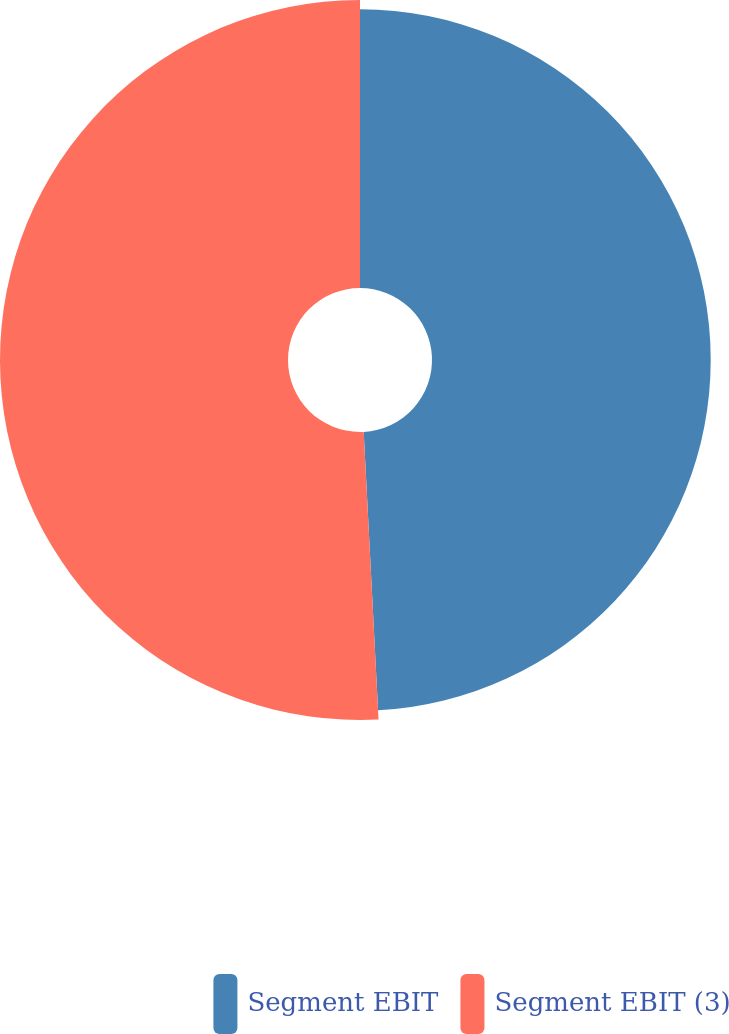<chart> <loc_0><loc_0><loc_500><loc_500><pie_chart><fcel>Segment EBIT<fcel>Segment EBIT (3)<nl><fcel>49.18%<fcel>50.82%<nl></chart> 